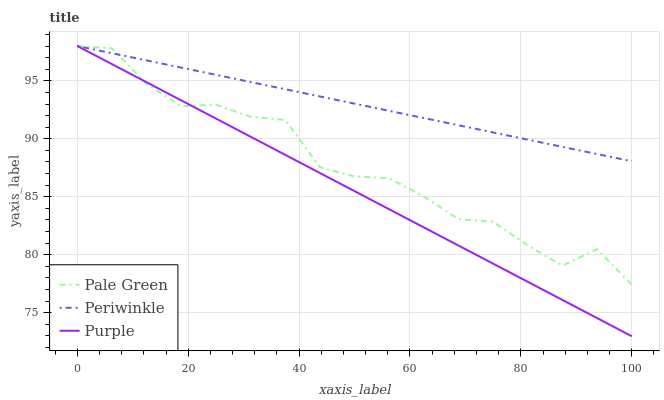Does Pale Green have the minimum area under the curve?
Answer yes or no. No. Does Pale Green have the maximum area under the curve?
Answer yes or no. No. Is Pale Green the smoothest?
Answer yes or no. No. Is Periwinkle the roughest?
Answer yes or no. No. Does Pale Green have the lowest value?
Answer yes or no. No. 